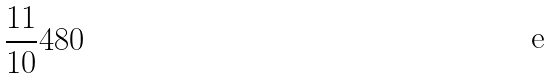<formula> <loc_0><loc_0><loc_500><loc_500>\frac { 1 1 } { 1 0 } 4 8 0</formula> 